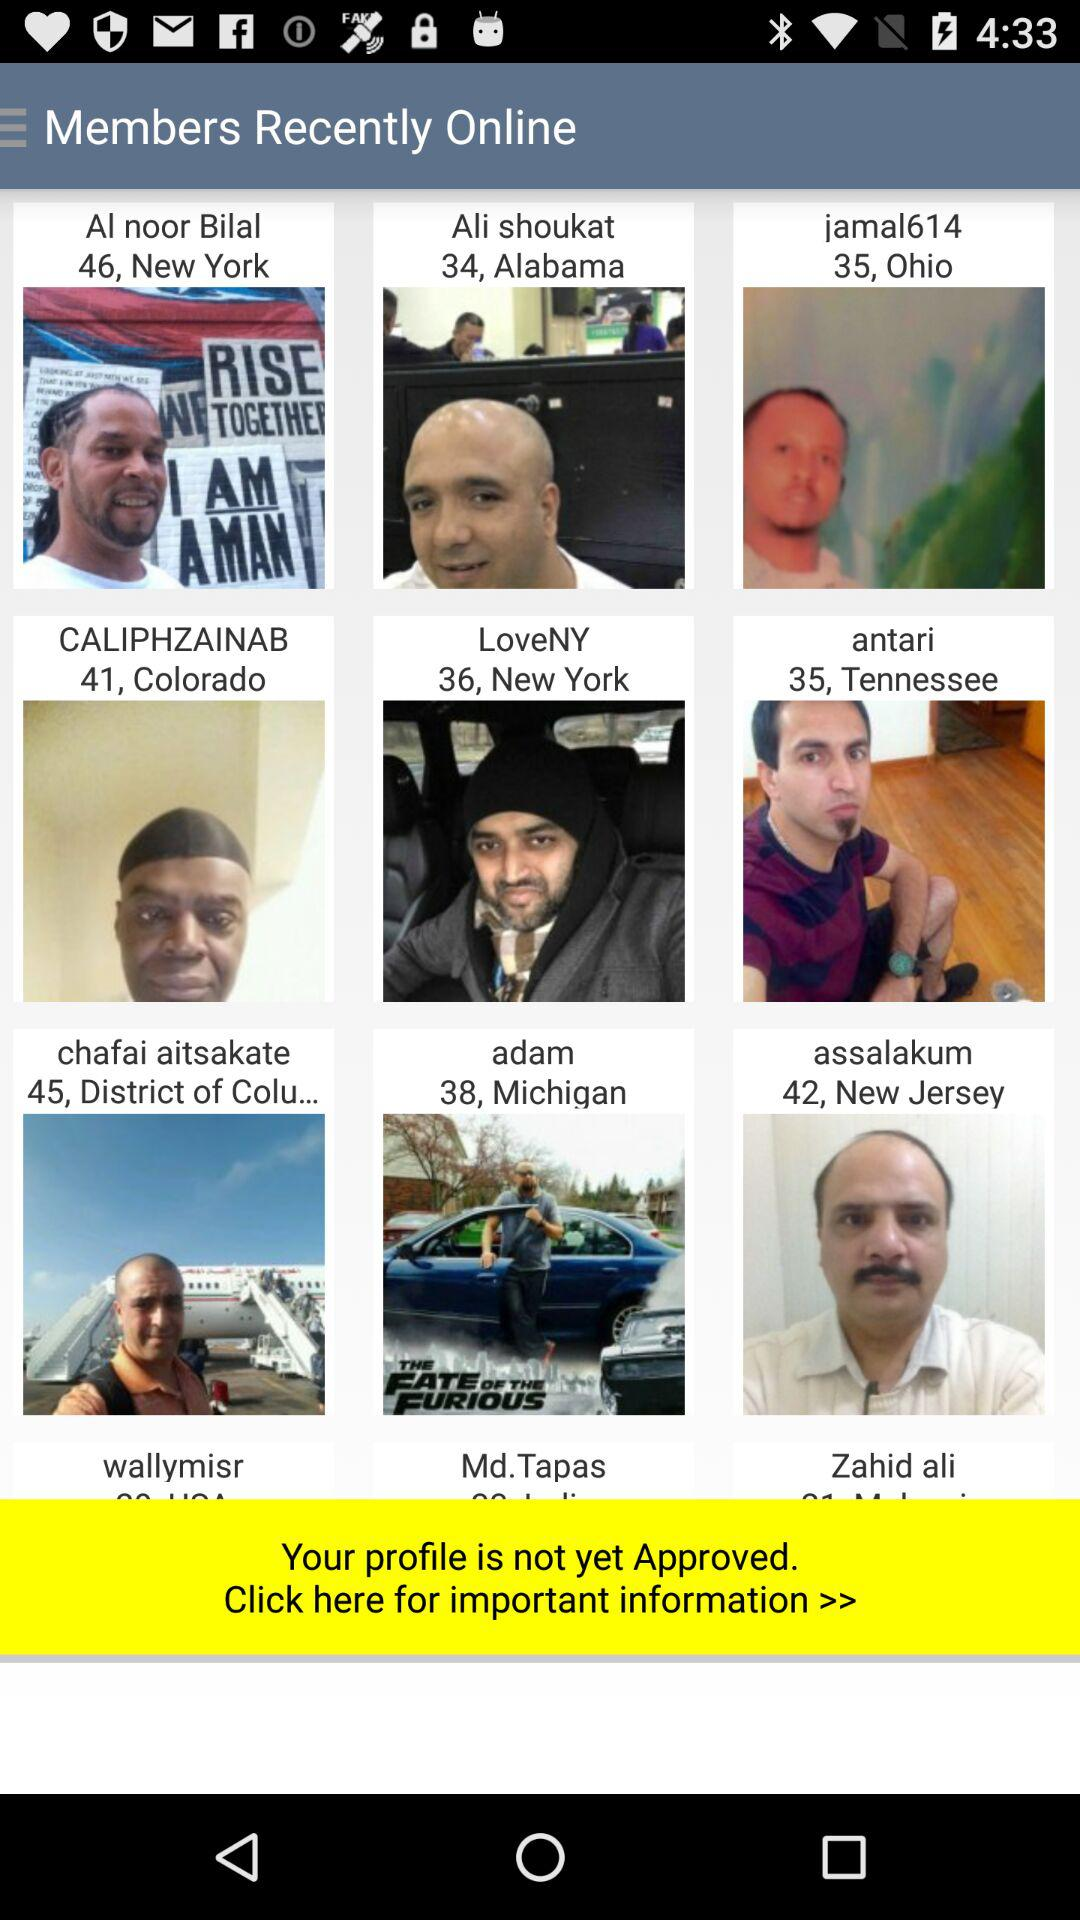What is the name of the person who belongs to New Jersey? The name of the person is Assalakum. 